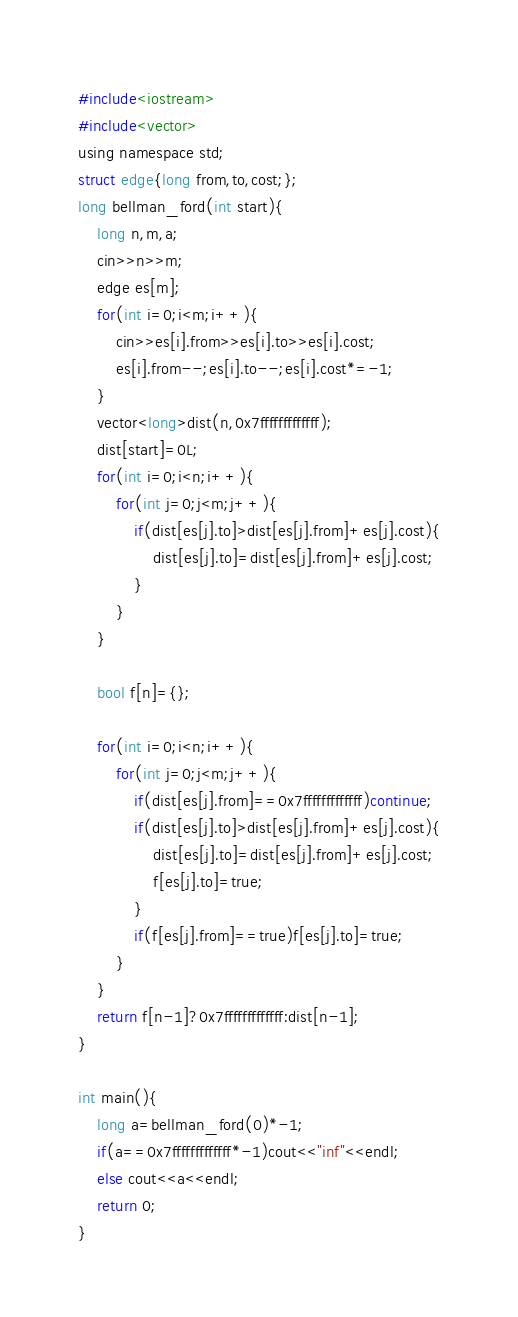<code> <loc_0><loc_0><loc_500><loc_500><_C_>#include<iostream>
#include<vector>
using namespace std;
struct edge{long from,to,cost;};
long bellman_ford(int start){
    long n,m,a;
    cin>>n>>m;
    edge es[m];
    for(int i=0;i<m;i++){
        cin>>es[i].from>>es[i].to>>es[i].cost;
        es[i].from--;es[i].to--;es[i].cost*=-1;
    }
    vector<long>dist(n,0x7fffffffffffff);
    dist[start]=0L;
    for(int i=0;i<n;i++){
        for(int j=0;j<m;j++){
            if(dist[es[j].to]>dist[es[j].from]+es[j].cost){
                dist[es[j].to]=dist[es[j].from]+es[j].cost;
            }
        }
    }
    
    bool f[n]={};
    
    for(int i=0;i<n;i++){
        for(int j=0;j<m;j++){
            if(dist[es[j].from]==0x7fffffffffffff)continue;
            if(dist[es[j].to]>dist[es[j].from]+es[j].cost){
                dist[es[j].to]=dist[es[j].from]+es[j].cost;
                f[es[j].to]=true;
            }
            if(f[es[j].from]==true)f[es[j].to]=true;
        }
    }
    return f[n-1]?0x7fffffffffffff:dist[n-1];
}

int main(){
    long a=bellman_ford(0)*-1;
    if(a==0x7fffffffffffff*-1)cout<<"inf"<<endl;
    else cout<<a<<endl;
    return 0;
}</code> 